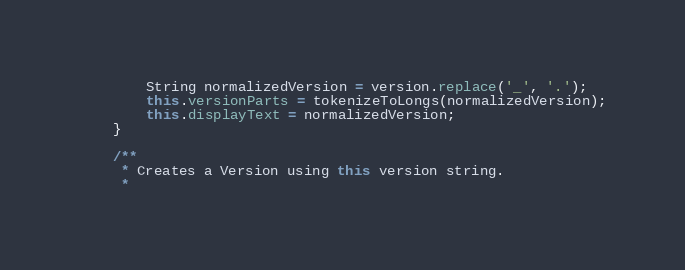Convert code to text. <code><loc_0><loc_0><loc_500><loc_500><_Java_>        String normalizedVersion = version.replace('_', '.');
        this.versionParts = tokenizeToLongs(normalizedVersion);
        this.displayText = normalizedVersion;
    }

    /**
     * Creates a Version using this version string.
     *</code> 